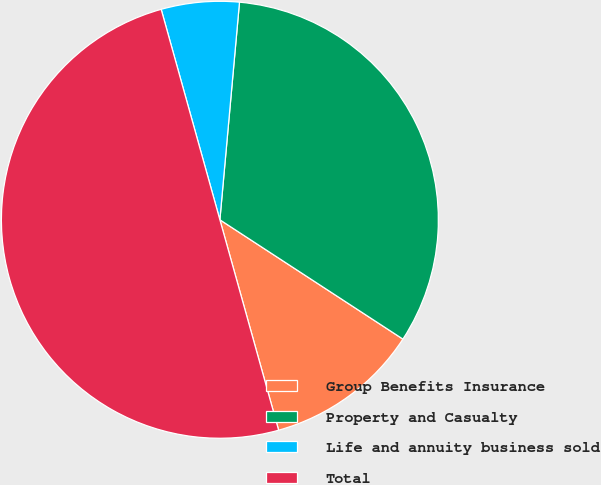<chart> <loc_0><loc_0><loc_500><loc_500><pie_chart><fcel>Group Benefits Insurance<fcel>Property and Casualty<fcel>Life and annuity business sold<fcel>Total<nl><fcel>11.47%<fcel>32.76%<fcel>5.76%<fcel>50.0%<nl></chart> 